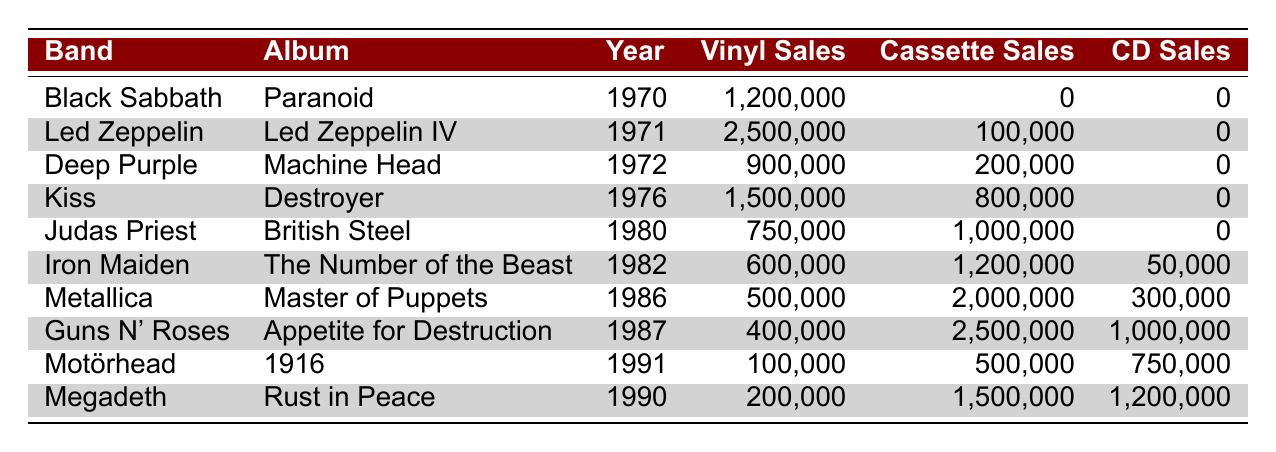What band had the highest vinyl sales? Looking at the table, Led Zeppelin sold 2,500,000 vinyl records, which is the highest among all listed bands.
Answer: Led Zeppelin What is the total number of cassette sales for Kiss and Judas Priest combined? Kiss sold 800,000 cassettes and Judas Priest sold 1,000,000 cassettes. Adding these together gives 800,000 + 1,000,000 = 1,800,000.
Answer: 1,800,000 Did Metallica release any albums in 1970? The table lists Metallica's album "Master of Puppets" as released in 1986, so they did not release any album in 1970.
Answer: No Which album had the least sales in the cassette category? The least cassette sales in the table is for Black Sabbath with 0 cassette sales.
Answer: Black Sabbath's "Paranoid" How many total sales (vinyl, cassette, and CD) did Guns N' Roses achieve? Guns N' Roses sold 400,000 vinyl, 2,500,000 cassettes, and 1,000,000 CDs. Summing these gives 400,000 + 2,500,000 + 1,000,000 = 3,900,000 total sales.
Answer: 3,900,000 Was "Rust in Peace" by Megadeth released before "The Number of the Beast" by Iron Maiden? The table shows that "The Number of the Beast" was released in 1982 and "Rust in Peace" was released in 1990, meaning "Rust in Peace" was released later.
Answer: No Which band had more cassette sales, Deep Purple or Iron Maiden? Deep Purple had 200,000 cassette sales while Iron Maiden had 1,200,000. Comparing these values, Iron Maiden had more cassette sales.
Answer: Iron Maiden What percentage of Iron Maiden's total sales were CDs? Iron Maiden's sales include 600,000 vinyl, 1,200,000 cassettes, and 50,000 CDs, totaling 600,000 + 1,200,000 + 50,000 = 1,850,000 sales. The percentage of CD sales is (50,000 / 1,850,000) * 100 = approximately 2.70%.
Answer: 2.70% Which year had the most total vinyl sales across all bands listed? By summing the vinyl sales from each year, we find that 1971 had the most vinyl sales: Led Zeppelin (2,500,000) + others = 2,500,000; other years have lower totals.
Answer: 1971 How many more vinyl albums did Black Sabbath sell compared to Motörhead? Black Sabbath sold 1,200,000 vinyl albums while Motörhead sold 100,000. The difference is 1,200,000 - 100,000 = 1,100,000 more vinyl sales for Black Sabbath.
Answer: 1,100,000 Which band had the highest total sales from all formats combined? By calculating the total sales for each band and comparing, Guns N' Roses had the highest combined sales of 3,900,000 (400,000 vinyl + 2,500,000 cassette + 1,000,000 CD).
Answer: Guns N' Roses 